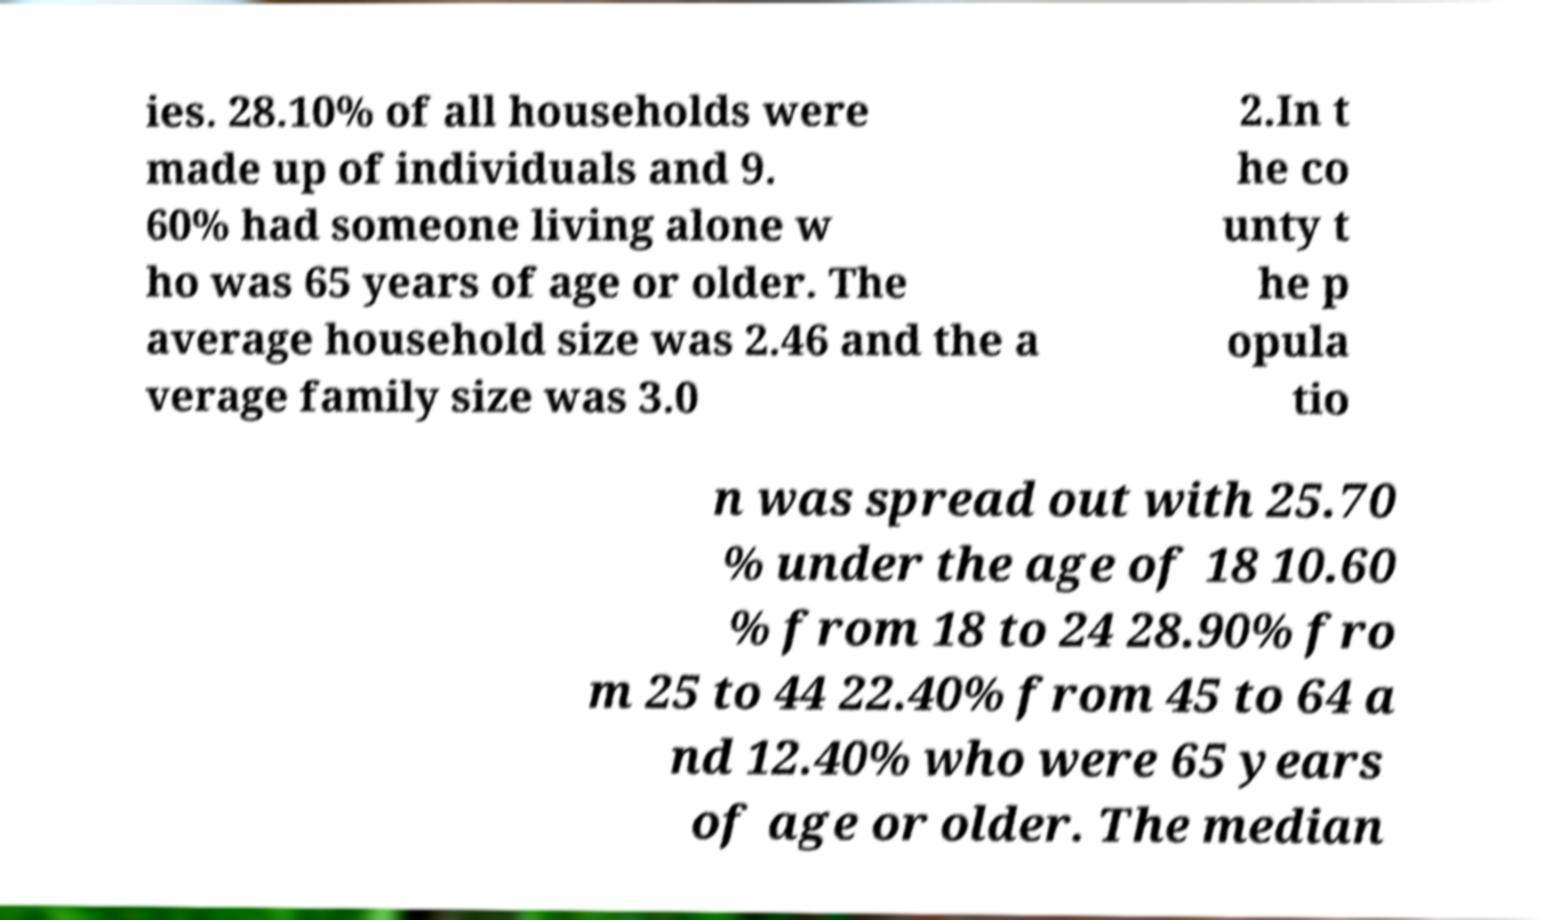Can you accurately transcribe the text from the provided image for me? ies. 28.10% of all households were made up of individuals and 9. 60% had someone living alone w ho was 65 years of age or older. The average household size was 2.46 and the a verage family size was 3.0 2.In t he co unty t he p opula tio n was spread out with 25.70 % under the age of 18 10.60 % from 18 to 24 28.90% fro m 25 to 44 22.40% from 45 to 64 a nd 12.40% who were 65 years of age or older. The median 